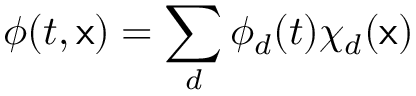<formula> <loc_0><loc_0><loc_500><loc_500>\phi ( t , x ) = \sum _ { d } \phi _ { d } ( t ) \chi _ { d } ( x )</formula> 